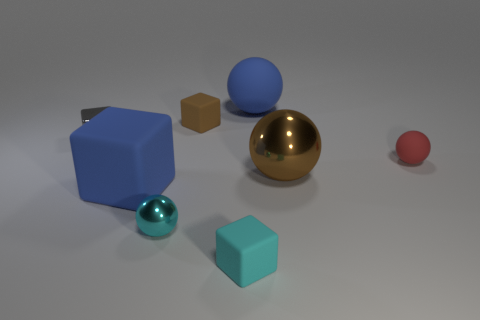There is a tiny gray thing that is the same shape as the cyan rubber thing; what material is it?
Offer a terse response. Metal. What shape is the big thing that is the same color as the large block?
Your answer should be compact. Sphere. Are there any big matte spheres that have the same color as the large matte block?
Offer a very short reply. Yes. There is a tiny gray metallic thing; are there any large rubber things behind it?
Your answer should be very brief. Yes. There is a red object; is it the same size as the shiny thing on the left side of the cyan metal thing?
Your response must be concise. Yes. What is the color of the large matte thing to the left of the tiny rubber thing behind the gray cube?
Ensure brevity in your answer.  Blue. Is the blue rubber ball the same size as the brown matte cube?
Offer a terse response. No. What color is the tiny rubber thing that is in front of the gray block and on the left side of the small rubber ball?
Give a very brief answer. Cyan. The cyan shiny object has what size?
Give a very brief answer. Small. There is a large matte object that is in front of the big blue matte sphere; does it have the same color as the big matte ball?
Your response must be concise. Yes. 